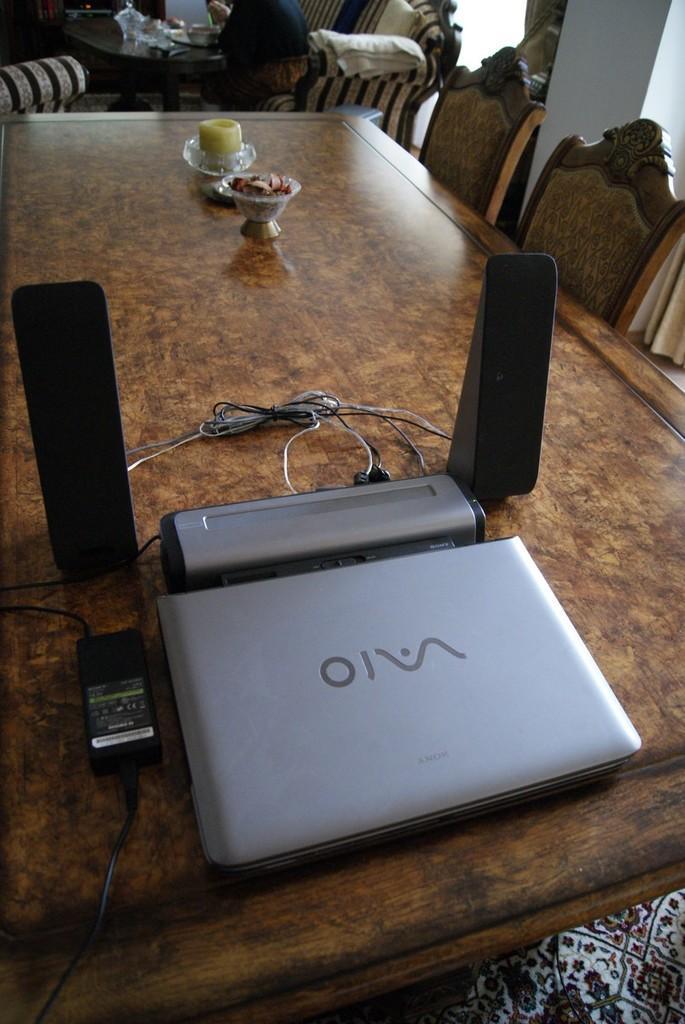Can you describe this image briefly? In this image there is a laptop and two speakers, two bowls are on the table which are surrounded by few chairs. Behind the table there is a person sitting on the sofa. Top of image there is a table having jar, bowl and few objects on it. Left side there is a chair. 